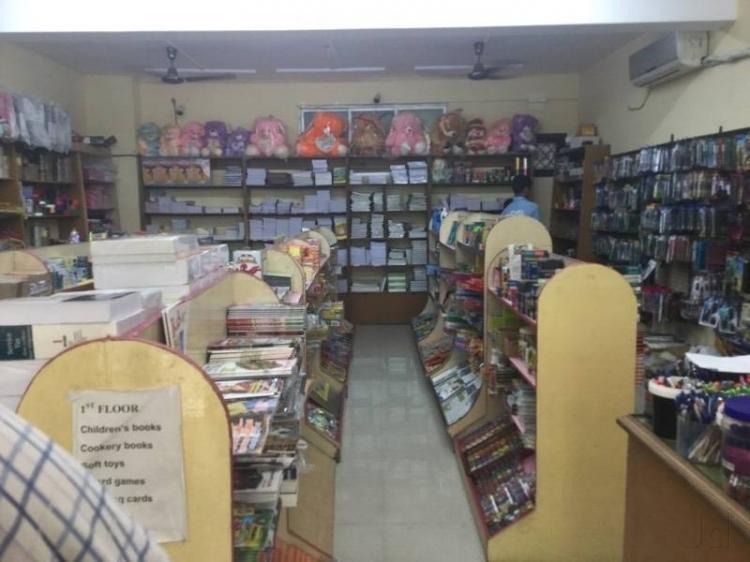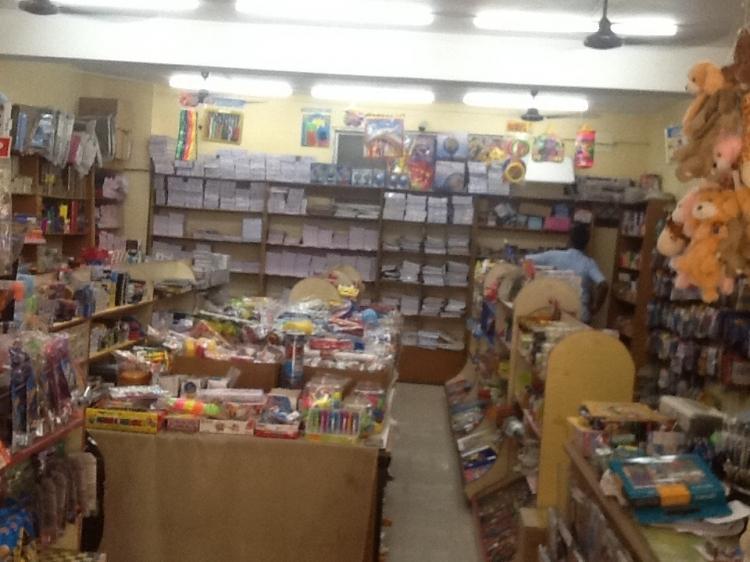The first image is the image on the left, the second image is the image on the right. Analyze the images presented: Is the assertion "People are looking at the merchandise." valid? Answer yes or no. Yes. The first image is the image on the left, the second image is the image on the right. Analyze the images presented: Is the assertion "In the book store there are at least 10 stuff bears ranging in color from pink, orange and purple sit on the top back self." valid? Answer yes or no. Yes. 